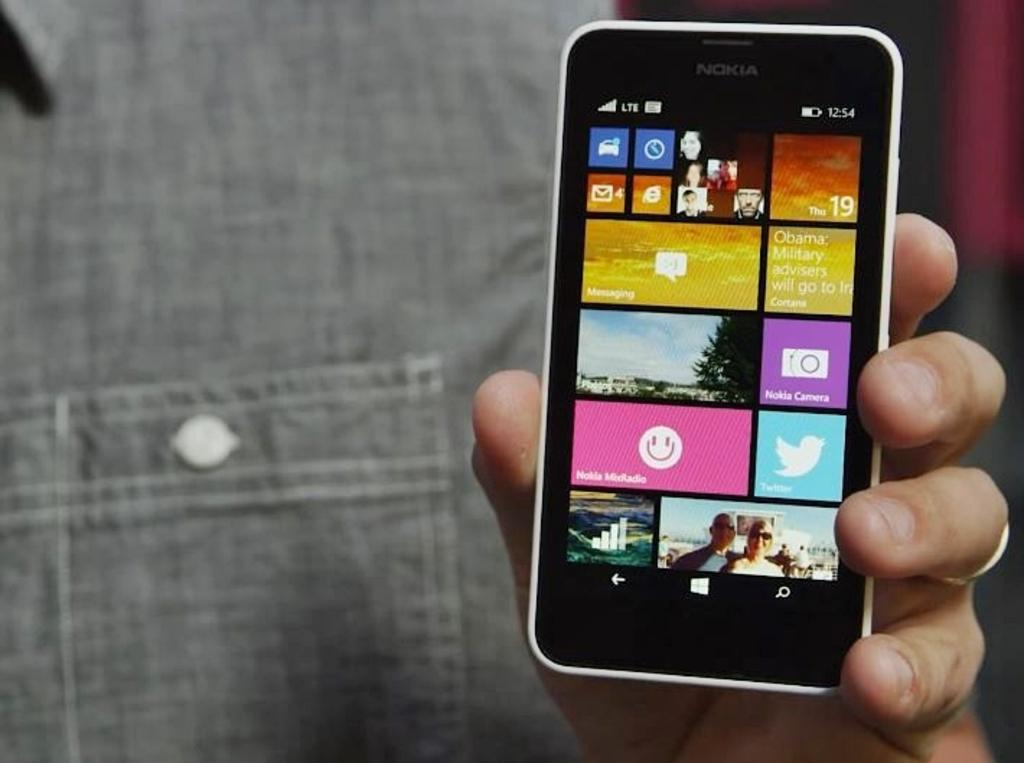<image>
Give a short and clear explanation of the subsequent image. the front of a nokia phone that shows the nokia midradio app 